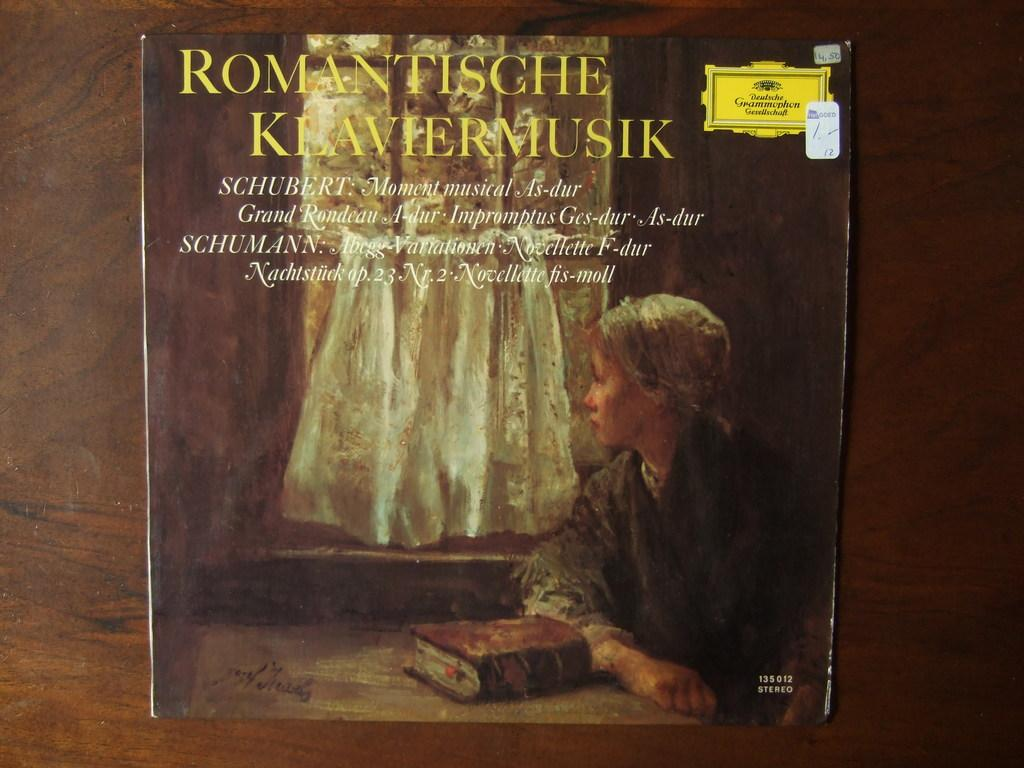<image>
Render a clear and concise summary of the photo. Music by Schubert is presented with a girl on the cover. 